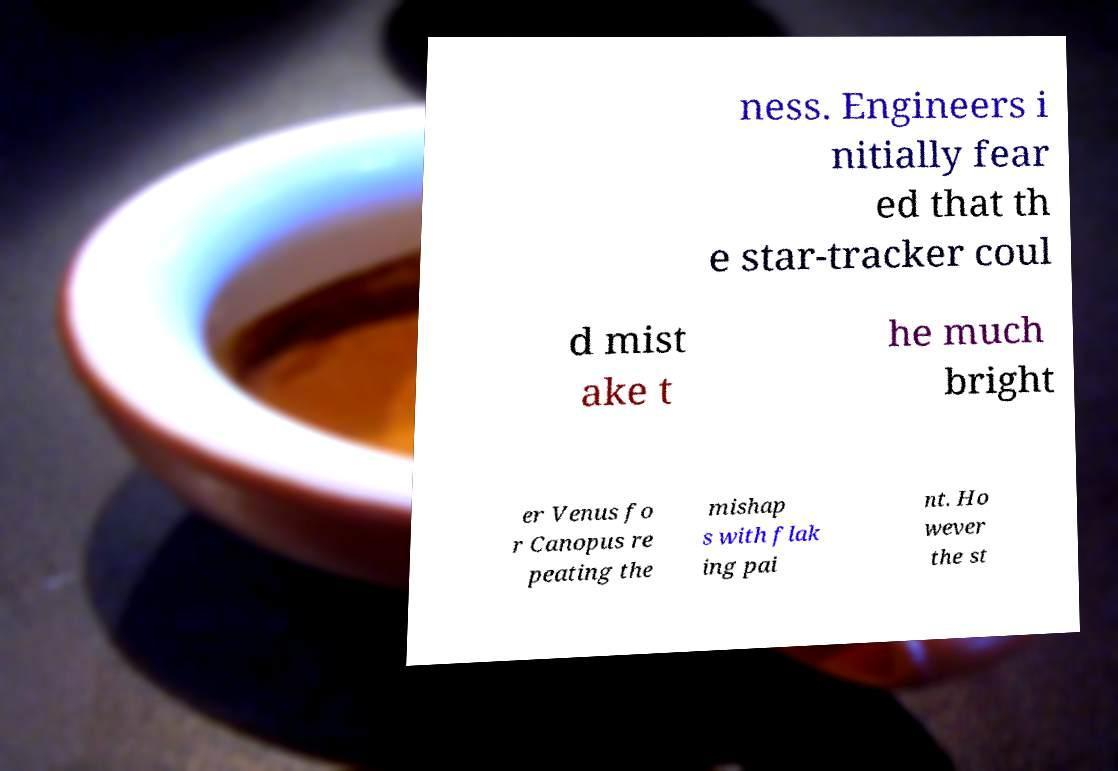There's text embedded in this image that I need extracted. Can you transcribe it verbatim? ness. Engineers i nitially fear ed that th e star-tracker coul d mist ake t he much bright er Venus fo r Canopus re peating the mishap s with flak ing pai nt. Ho wever the st 